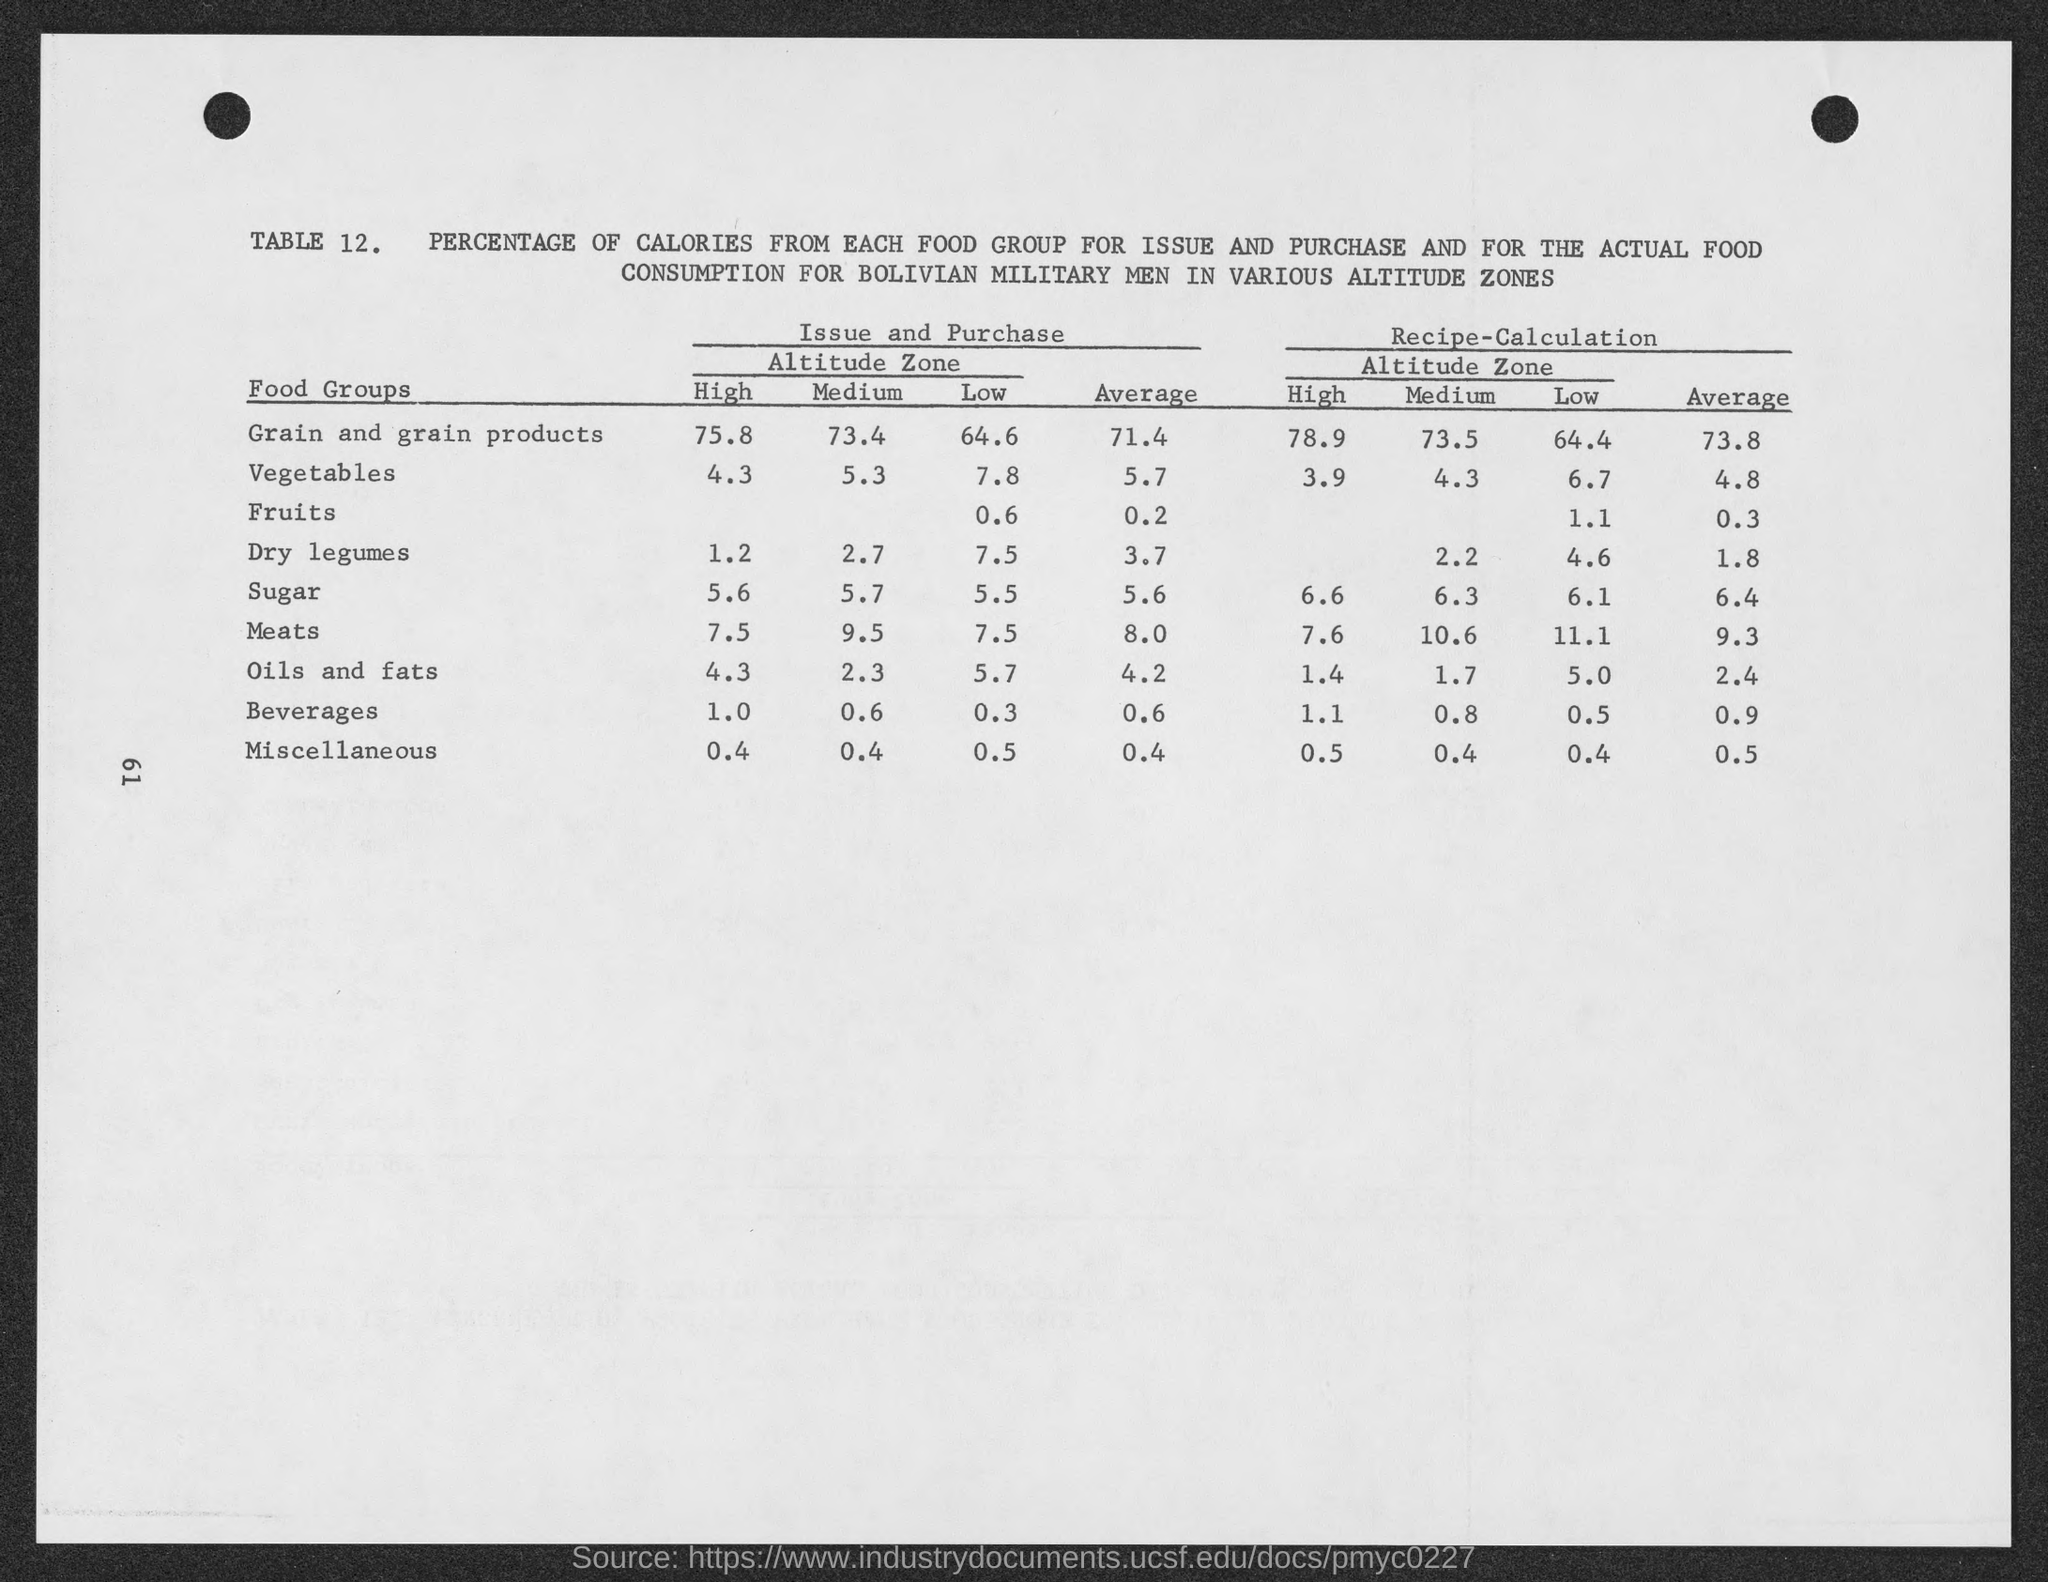List a handful of essential elements in this visual. The average percentage of recipe calculation in grain and grain products is 73.8%. 